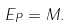Convert formula to latex. <formula><loc_0><loc_0><loc_500><loc_500>E _ { P } = M .</formula> 